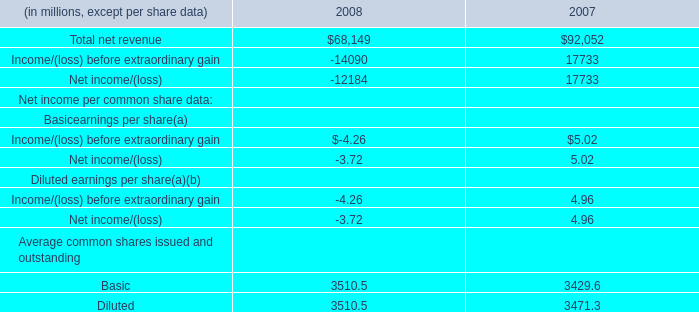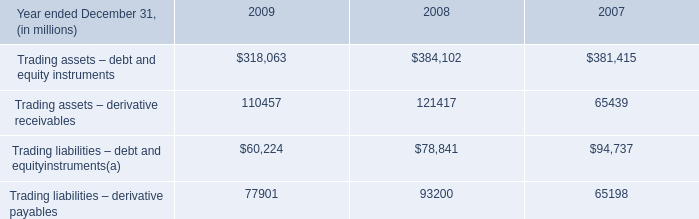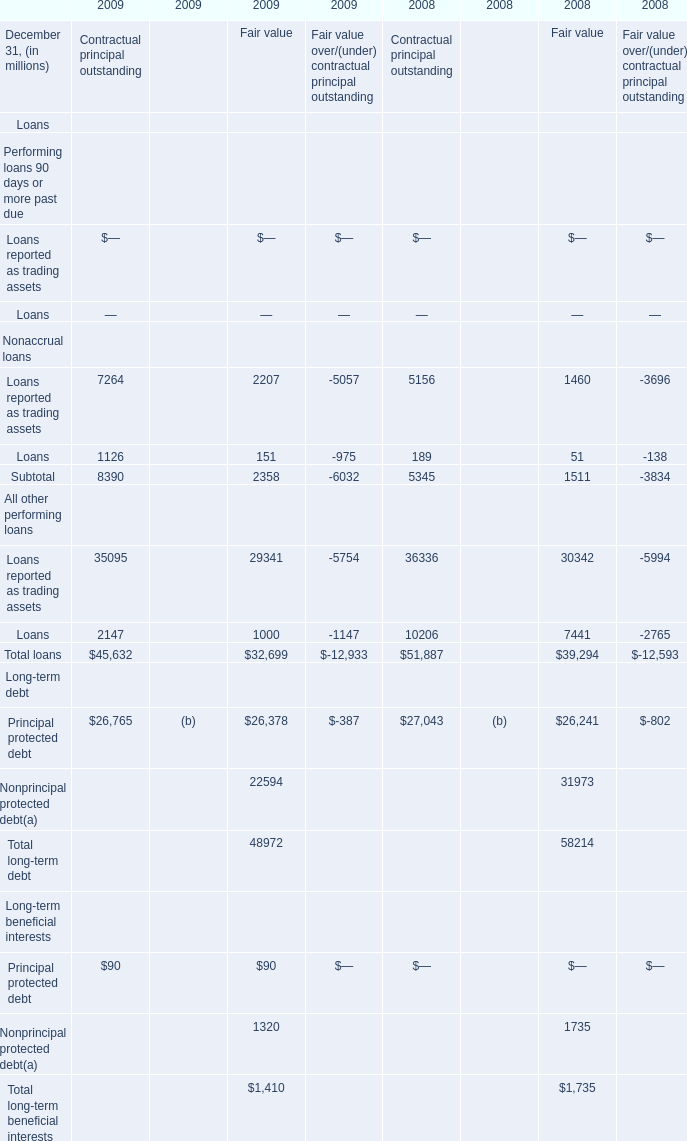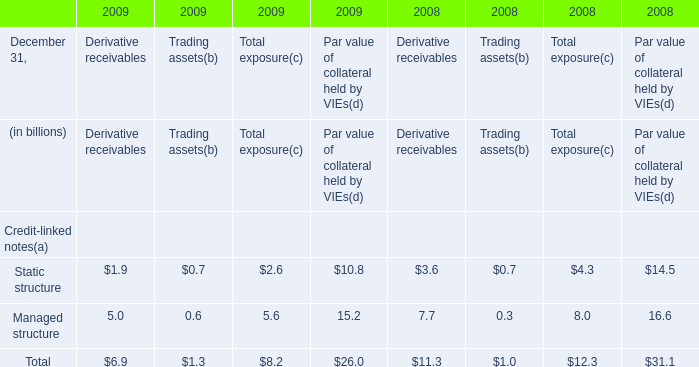What is the average amount of Basic Average common shares issued and outstanding of 2008, and Trading assets – derivative receivables of 2008 ? 
Computations: ((3510.5 + 121417.0) / 2)
Answer: 62463.75. 